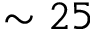<formula> <loc_0><loc_0><loc_500><loc_500>\sim 2 5</formula> 